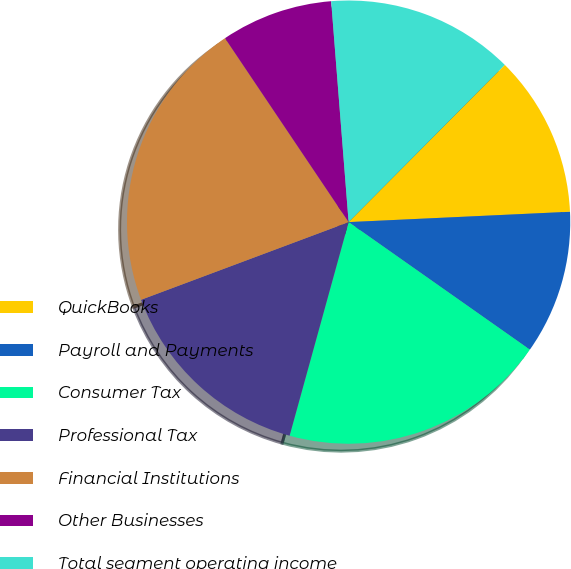<chart> <loc_0><loc_0><loc_500><loc_500><pie_chart><fcel>QuickBooks<fcel>Payroll and Payments<fcel>Consumer Tax<fcel>Professional Tax<fcel>Financial Institutions<fcel>Other Businesses<fcel>Total segment operating income<nl><fcel>11.81%<fcel>10.5%<fcel>19.53%<fcel>15.01%<fcel>21.28%<fcel>8.16%<fcel>13.7%<nl></chart> 